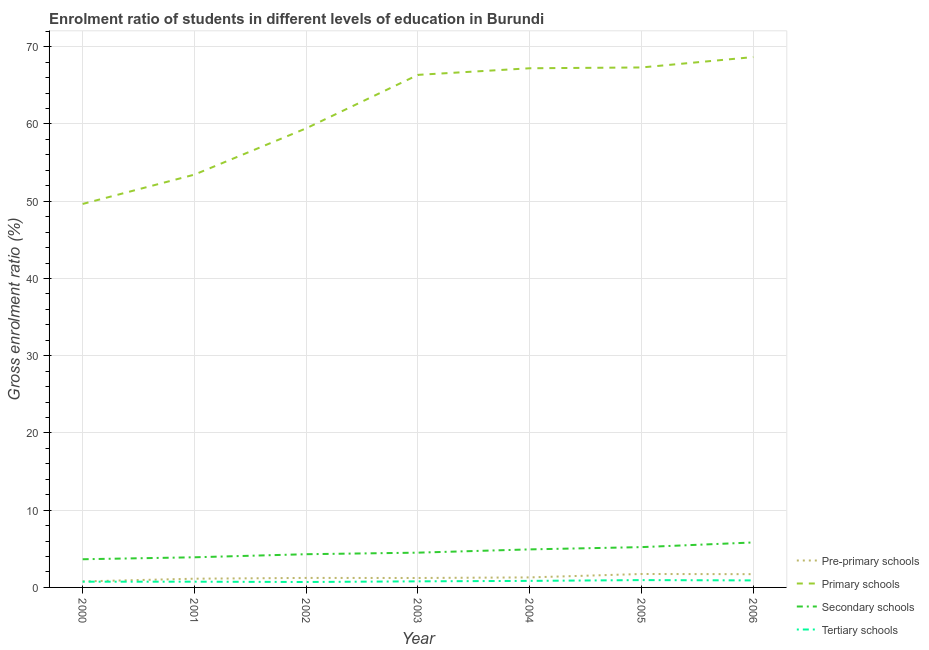How many different coloured lines are there?
Give a very brief answer. 4. Does the line corresponding to gross enrolment ratio in tertiary schools intersect with the line corresponding to gross enrolment ratio in secondary schools?
Make the answer very short. No. Is the number of lines equal to the number of legend labels?
Your response must be concise. Yes. What is the gross enrolment ratio in primary schools in 2002?
Ensure brevity in your answer.  59.44. Across all years, what is the maximum gross enrolment ratio in pre-primary schools?
Keep it short and to the point. 1.74. Across all years, what is the minimum gross enrolment ratio in pre-primary schools?
Give a very brief answer. 0.78. In which year was the gross enrolment ratio in secondary schools maximum?
Keep it short and to the point. 2006. In which year was the gross enrolment ratio in secondary schools minimum?
Ensure brevity in your answer.  2000. What is the total gross enrolment ratio in secondary schools in the graph?
Ensure brevity in your answer.  32.32. What is the difference between the gross enrolment ratio in primary schools in 2001 and that in 2002?
Your response must be concise. -5.99. What is the difference between the gross enrolment ratio in secondary schools in 2000 and the gross enrolment ratio in primary schools in 2003?
Offer a terse response. -62.71. What is the average gross enrolment ratio in pre-primary schools per year?
Give a very brief answer. 1.3. In the year 2001, what is the difference between the gross enrolment ratio in secondary schools and gross enrolment ratio in primary schools?
Keep it short and to the point. -49.54. What is the ratio of the gross enrolment ratio in pre-primary schools in 2000 to that in 2004?
Your response must be concise. 0.6. Is the gross enrolment ratio in primary schools in 2002 less than that in 2003?
Provide a succinct answer. Yes. Is the difference between the gross enrolment ratio in primary schools in 2000 and 2004 greater than the difference between the gross enrolment ratio in pre-primary schools in 2000 and 2004?
Ensure brevity in your answer.  No. What is the difference between the highest and the second highest gross enrolment ratio in tertiary schools?
Your answer should be compact. 0.04. What is the difference between the highest and the lowest gross enrolment ratio in tertiary schools?
Make the answer very short. 0.25. Is the sum of the gross enrolment ratio in tertiary schools in 2000 and 2003 greater than the maximum gross enrolment ratio in pre-primary schools across all years?
Ensure brevity in your answer.  No. Does the gross enrolment ratio in secondary schools monotonically increase over the years?
Offer a terse response. Yes. What is the difference between two consecutive major ticks on the Y-axis?
Give a very brief answer. 10. Where does the legend appear in the graph?
Make the answer very short. Bottom right. How many legend labels are there?
Keep it short and to the point. 4. What is the title of the graph?
Keep it short and to the point. Enrolment ratio of students in different levels of education in Burundi. Does "Regional development banks" appear as one of the legend labels in the graph?
Make the answer very short. No. What is the Gross enrolment ratio (%) in Pre-primary schools in 2000?
Your answer should be compact. 0.78. What is the Gross enrolment ratio (%) of Primary schools in 2000?
Ensure brevity in your answer.  49.65. What is the Gross enrolment ratio (%) of Secondary schools in 2000?
Offer a very short reply. 3.65. What is the Gross enrolment ratio (%) of Tertiary schools in 2000?
Keep it short and to the point. 0.74. What is the Gross enrolment ratio (%) of Pre-primary schools in 2001?
Your answer should be very brief. 1.13. What is the Gross enrolment ratio (%) of Primary schools in 2001?
Give a very brief answer. 53.45. What is the Gross enrolment ratio (%) in Secondary schools in 2001?
Your response must be concise. 3.9. What is the Gross enrolment ratio (%) of Tertiary schools in 2001?
Give a very brief answer. 0.74. What is the Gross enrolment ratio (%) in Pre-primary schools in 2002?
Make the answer very short. 1.23. What is the Gross enrolment ratio (%) of Primary schools in 2002?
Your answer should be compact. 59.44. What is the Gross enrolment ratio (%) of Secondary schools in 2002?
Your answer should be very brief. 4.3. What is the Gross enrolment ratio (%) of Tertiary schools in 2002?
Your response must be concise. 0.7. What is the Gross enrolment ratio (%) of Pre-primary schools in 2003?
Offer a very short reply. 1.22. What is the Gross enrolment ratio (%) in Primary schools in 2003?
Your answer should be compact. 66.36. What is the Gross enrolment ratio (%) in Secondary schools in 2003?
Provide a short and direct response. 4.5. What is the Gross enrolment ratio (%) of Tertiary schools in 2003?
Your response must be concise. 0.79. What is the Gross enrolment ratio (%) in Pre-primary schools in 2004?
Provide a succinct answer. 1.3. What is the Gross enrolment ratio (%) in Primary schools in 2004?
Keep it short and to the point. 67.22. What is the Gross enrolment ratio (%) in Secondary schools in 2004?
Offer a very short reply. 4.93. What is the Gross enrolment ratio (%) in Tertiary schools in 2004?
Offer a very short reply. 0.85. What is the Gross enrolment ratio (%) of Pre-primary schools in 2005?
Provide a short and direct response. 1.74. What is the Gross enrolment ratio (%) in Primary schools in 2005?
Your answer should be very brief. 67.32. What is the Gross enrolment ratio (%) of Secondary schools in 2005?
Your response must be concise. 5.22. What is the Gross enrolment ratio (%) in Tertiary schools in 2005?
Ensure brevity in your answer.  0.95. What is the Gross enrolment ratio (%) of Pre-primary schools in 2006?
Give a very brief answer. 1.72. What is the Gross enrolment ratio (%) of Primary schools in 2006?
Offer a very short reply. 68.67. What is the Gross enrolment ratio (%) in Secondary schools in 2006?
Offer a terse response. 5.82. What is the Gross enrolment ratio (%) in Tertiary schools in 2006?
Your answer should be very brief. 0.91. Across all years, what is the maximum Gross enrolment ratio (%) of Pre-primary schools?
Offer a very short reply. 1.74. Across all years, what is the maximum Gross enrolment ratio (%) in Primary schools?
Your answer should be compact. 68.67. Across all years, what is the maximum Gross enrolment ratio (%) in Secondary schools?
Provide a succinct answer. 5.82. Across all years, what is the maximum Gross enrolment ratio (%) in Tertiary schools?
Ensure brevity in your answer.  0.95. Across all years, what is the minimum Gross enrolment ratio (%) of Pre-primary schools?
Offer a very short reply. 0.78. Across all years, what is the minimum Gross enrolment ratio (%) of Primary schools?
Keep it short and to the point. 49.65. Across all years, what is the minimum Gross enrolment ratio (%) of Secondary schools?
Provide a short and direct response. 3.65. Across all years, what is the minimum Gross enrolment ratio (%) of Tertiary schools?
Offer a terse response. 0.7. What is the total Gross enrolment ratio (%) of Pre-primary schools in the graph?
Provide a short and direct response. 9.12. What is the total Gross enrolment ratio (%) in Primary schools in the graph?
Ensure brevity in your answer.  432.1. What is the total Gross enrolment ratio (%) in Secondary schools in the graph?
Your answer should be very brief. 32.32. What is the total Gross enrolment ratio (%) of Tertiary schools in the graph?
Offer a very short reply. 5.68. What is the difference between the Gross enrolment ratio (%) of Pre-primary schools in 2000 and that in 2001?
Ensure brevity in your answer.  -0.35. What is the difference between the Gross enrolment ratio (%) in Primary schools in 2000 and that in 2001?
Give a very brief answer. -3.8. What is the difference between the Gross enrolment ratio (%) of Secondary schools in 2000 and that in 2001?
Your answer should be very brief. -0.25. What is the difference between the Gross enrolment ratio (%) of Tertiary schools in 2000 and that in 2001?
Keep it short and to the point. 0. What is the difference between the Gross enrolment ratio (%) of Pre-primary schools in 2000 and that in 2002?
Keep it short and to the point. -0.45. What is the difference between the Gross enrolment ratio (%) of Primary schools in 2000 and that in 2002?
Provide a succinct answer. -9.79. What is the difference between the Gross enrolment ratio (%) of Secondary schools in 2000 and that in 2002?
Your response must be concise. -0.65. What is the difference between the Gross enrolment ratio (%) of Tertiary schools in 2000 and that in 2002?
Provide a succinct answer. 0.04. What is the difference between the Gross enrolment ratio (%) of Pre-primary schools in 2000 and that in 2003?
Your response must be concise. -0.44. What is the difference between the Gross enrolment ratio (%) of Primary schools in 2000 and that in 2003?
Your answer should be compact. -16.71. What is the difference between the Gross enrolment ratio (%) in Secondary schools in 2000 and that in 2003?
Provide a short and direct response. -0.85. What is the difference between the Gross enrolment ratio (%) in Tertiary schools in 2000 and that in 2003?
Give a very brief answer. -0.04. What is the difference between the Gross enrolment ratio (%) in Pre-primary schools in 2000 and that in 2004?
Offer a very short reply. -0.52. What is the difference between the Gross enrolment ratio (%) in Primary schools in 2000 and that in 2004?
Make the answer very short. -17.57. What is the difference between the Gross enrolment ratio (%) in Secondary schools in 2000 and that in 2004?
Offer a very short reply. -1.28. What is the difference between the Gross enrolment ratio (%) of Tertiary schools in 2000 and that in 2004?
Offer a very short reply. -0.1. What is the difference between the Gross enrolment ratio (%) in Pre-primary schools in 2000 and that in 2005?
Make the answer very short. -0.96. What is the difference between the Gross enrolment ratio (%) in Primary schools in 2000 and that in 2005?
Provide a short and direct response. -17.67. What is the difference between the Gross enrolment ratio (%) in Secondary schools in 2000 and that in 2005?
Provide a short and direct response. -1.57. What is the difference between the Gross enrolment ratio (%) of Tertiary schools in 2000 and that in 2005?
Offer a terse response. -0.21. What is the difference between the Gross enrolment ratio (%) of Pre-primary schools in 2000 and that in 2006?
Make the answer very short. -0.94. What is the difference between the Gross enrolment ratio (%) in Primary schools in 2000 and that in 2006?
Provide a succinct answer. -19.02. What is the difference between the Gross enrolment ratio (%) in Secondary schools in 2000 and that in 2006?
Your answer should be very brief. -2.17. What is the difference between the Gross enrolment ratio (%) in Tertiary schools in 2000 and that in 2006?
Keep it short and to the point. -0.16. What is the difference between the Gross enrolment ratio (%) in Pre-primary schools in 2001 and that in 2002?
Your response must be concise. -0.1. What is the difference between the Gross enrolment ratio (%) of Primary schools in 2001 and that in 2002?
Make the answer very short. -5.99. What is the difference between the Gross enrolment ratio (%) of Secondary schools in 2001 and that in 2002?
Provide a succinct answer. -0.4. What is the difference between the Gross enrolment ratio (%) in Tertiary schools in 2001 and that in 2002?
Offer a very short reply. 0.04. What is the difference between the Gross enrolment ratio (%) of Pre-primary schools in 2001 and that in 2003?
Your response must be concise. -0.09. What is the difference between the Gross enrolment ratio (%) in Primary schools in 2001 and that in 2003?
Make the answer very short. -12.92. What is the difference between the Gross enrolment ratio (%) in Secondary schools in 2001 and that in 2003?
Your response must be concise. -0.6. What is the difference between the Gross enrolment ratio (%) in Tertiary schools in 2001 and that in 2003?
Ensure brevity in your answer.  -0.04. What is the difference between the Gross enrolment ratio (%) in Pre-primary schools in 2001 and that in 2004?
Give a very brief answer. -0.17. What is the difference between the Gross enrolment ratio (%) in Primary schools in 2001 and that in 2004?
Your answer should be very brief. -13.77. What is the difference between the Gross enrolment ratio (%) of Secondary schools in 2001 and that in 2004?
Provide a short and direct response. -1.02. What is the difference between the Gross enrolment ratio (%) in Tertiary schools in 2001 and that in 2004?
Ensure brevity in your answer.  -0.1. What is the difference between the Gross enrolment ratio (%) of Pre-primary schools in 2001 and that in 2005?
Ensure brevity in your answer.  -0.61. What is the difference between the Gross enrolment ratio (%) of Primary schools in 2001 and that in 2005?
Your answer should be very brief. -13.87. What is the difference between the Gross enrolment ratio (%) in Secondary schools in 2001 and that in 2005?
Ensure brevity in your answer.  -1.32. What is the difference between the Gross enrolment ratio (%) of Tertiary schools in 2001 and that in 2005?
Ensure brevity in your answer.  -0.21. What is the difference between the Gross enrolment ratio (%) in Pre-primary schools in 2001 and that in 2006?
Provide a short and direct response. -0.59. What is the difference between the Gross enrolment ratio (%) of Primary schools in 2001 and that in 2006?
Offer a terse response. -15.22. What is the difference between the Gross enrolment ratio (%) in Secondary schools in 2001 and that in 2006?
Keep it short and to the point. -1.92. What is the difference between the Gross enrolment ratio (%) of Tertiary schools in 2001 and that in 2006?
Ensure brevity in your answer.  -0.16. What is the difference between the Gross enrolment ratio (%) in Pre-primary schools in 2002 and that in 2003?
Provide a short and direct response. 0.01. What is the difference between the Gross enrolment ratio (%) in Primary schools in 2002 and that in 2003?
Provide a short and direct response. -6.92. What is the difference between the Gross enrolment ratio (%) in Secondary schools in 2002 and that in 2003?
Your response must be concise. -0.2. What is the difference between the Gross enrolment ratio (%) in Tertiary schools in 2002 and that in 2003?
Keep it short and to the point. -0.08. What is the difference between the Gross enrolment ratio (%) of Pre-primary schools in 2002 and that in 2004?
Give a very brief answer. -0.07. What is the difference between the Gross enrolment ratio (%) of Primary schools in 2002 and that in 2004?
Your answer should be compact. -7.78. What is the difference between the Gross enrolment ratio (%) in Secondary schools in 2002 and that in 2004?
Give a very brief answer. -0.63. What is the difference between the Gross enrolment ratio (%) of Tertiary schools in 2002 and that in 2004?
Provide a short and direct response. -0.14. What is the difference between the Gross enrolment ratio (%) in Pre-primary schools in 2002 and that in 2005?
Your answer should be compact. -0.51. What is the difference between the Gross enrolment ratio (%) in Primary schools in 2002 and that in 2005?
Your answer should be very brief. -7.88. What is the difference between the Gross enrolment ratio (%) of Secondary schools in 2002 and that in 2005?
Ensure brevity in your answer.  -0.92. What is the difference between the Gross enrolment ratio (%) in Tertiary schools in 2002 and that in 2005?
Offer a terse response. -0.25. What is the difference between the Gross enrolment ratio (%) of Pre-primary schools in 2002 and that in 2006?
Provide a succinct answer. -0.49. What is the difference between the Gross enrolment ratio (%) of Primary schools in 2002 and that in 2006?
Ensure brevity in your answer.  -9.22. What is the difference between the Gross enrolment ratio (%) in Secondary schools in 2002 and that in 2006?
Give a very brief answer. -1.52. What is the difference between the Gross enrolment ratio (%) of Tertiary schools in 2002 and that in 2006?
Provide a succinct answer. -0.2. What is the difference between the Gross enrolment ratio (%) of Pre-primary schools in 2003 and that in 2004?
Offer a terse response. -0.07. What is the difference between the Gross enrolment ratio (%) in Primary schools in 2003 and that in 2004?
Provide a succinct answer. -0.85. What is the difference between the Gross enrolment ratio (%) of Secondary schools in 2003 and that in 2004?
Your answer should be very brief. -0.42. What is the difference between the Gross enrolment ratio (%) in Tertiary schools in 2003 and that in 2004?
Your answer should be very brief. -0.06. What is the difference between the Gross enrolment ratio (%) in Pre-primary schools in 2003 and that in 2005?
Provide a succinct answer. -0.52. What is the difference between the Gross enrolment ratio (%) of Primary schools in 2003 and that in 2005?
Keep it short and to the point. -0.96. What is the difference between the Gross enrolment ratio (%) in Secondary schools in 2003 and that in 2005?
Your answer should be very brief. -0.72. What is the difference between the Gross enrolment ratio (%) of Tertiary schools in 2003 and that in 2005?
Offer a very short reply. -0.16. What is the difference between the Gross enrolment ratio (%) in Pre-primary schools in 2003 and that in 2006?
Keep it short and to the point. -0.49. What is the difference between the Gross enrolment ratio (%) of Primary schools in 2003 and that in 2006?
Provide a short and direct response. -2.3. What is the difference between the Gross enrolment ratio (%) of Secondary schools in 2003 and that in 2006?
Your response must be concise. -1.32. What is the difference between the Gross enrolment ratio (%) in Tertiary schools in 2003 and that in 2006?
Ensure brevity in your answer.  -0.12. What is the difference between the Gross enrolment ratio (%) in Pre-primary schools in 2004 and that in 2005?
Ensure brevity in your answer.  -0.44. What is the difference between the Gross enrolment ratio (%) in Primary schools in 2004 and that in 2005?
Provide a short and direct response. -0.1. What is the difference between the Gross enrolment ratio (%) in Secondary schools in 2004 and that in 2005?
Provide a succinct answer. -0.29. What is the difference between the Gross enrolment ratio (%) of Tertiary schools in 2004 and that in 2005?
Offer a terse response. -0.1. What is the difference between the Gross enrolment ratio (%) in Pre-primary schools in 2004 and that in 2006?
Give a very brief answer. -0.42. What is the difference between the Gross enrolment ratio (%) in Primary schools in 2004 and that in 2006?
Give a very brief answer. -1.45. What is the difference between the Gross enrolment ratio (%) in Secondary schools in 2004 and that in 2006?
Keep it short and to the point. -0.9. What is the difference between the Gross enrolment ratio (%) in Tertiary schools in 2004 and that in 2006?
Make the answer very short. -0.06. What is the difference between the Gross enrolment ratio (%) in Pre-primary schools in 2005 and that in 2006?
Your answer should be very brief. 0.02. What is the difference between the Gross enrolment ratio (%) of Primary schools in 2005 and that in 2006?
Your answer should be compact. -1.34. What is the difference between the Gross enrolment ratio (%) in Secondary schools in 2005 and that in 2006?
Ensure brevity in your answer.  -0.6. What is the difference between the Gross enrolment ratio (%) in Tertiary schools in 2005 and that in 2006?
Your response must be concise. 0.04. What is the difference between the Gross enrolment ratio (%) in Pre-primary schools in 2000 and the Gross enrolment ratio (%) in Primary schools in 2001?
Your answer should be compact. -52.67. What is the difference between the Gross enrolment ratio (%) in Pre-primary schools in 2000 and the Gross enrolment ratio (%) in Secondary schools in 2001?
Make the answer very short. -3.12. What is the difference between the Gross enrolment ratio (%) of Pre-primary schools in 2000 and the Gross enrolment ratio (%) of Tertiary schools in 2001?
Provide a succinct answer. 0.04. What is the difference between the Gross enrolment ratio (%) of Primary schools in 2000 and the Gross enrolment ratio (%) of Secondary schools in 2001?
Offer a very short reply. 45.75. What is the difference between the Gross enrolment ratio (%) of Primary schools in 2000 and the Gross enrolment ratio (%) of Tertiary schools in 2001?
Your answer should be compact. 48.91. What is the difference between the Gross enrolment ratio (%) of Secondary schools in 2000 and the Gross enrolment ratio (%) of Tertiary schools in 2001?
Make the answer very short. 2.91. What is the difference between the Gross enrolment ratio (%) in Pre-primary schools in 2000 and the Gross enrolment ratio (%) in Primary schools in 2002?
Ensure brevity in your answer.  -58.66. What is the difference between the Gross enrolment ratio (%) of Pre-primary schools in 2000 and the Gross enrolment ratio (%) of Secondary schools in 2002?
Keep it short and to the point. -3.52. What is the difference between the Gross enrolment ratio (%) of Pre-primary schools in 2000 and the Gross enrolment ratio (%) of Tertiary schools in 2002?
Give a very brief answer. 0.07. What is the difference between the Gross enrolment ratio (%) in Primary schools in 2000 and the Gross enrolment ratio (%) in Secondary schools in 2002?
Offer a terse response. 45.35. What is the difference between the Gross enrolment ratio (%) of Primary schools in 2000 and the Gross enrolment ratio (%) of Tertiary schools in 2002?
Make the answer very short. 48.95. What is the difference between the Gross enrolment ratio (%) in Secondary schools in 2000 and the Gross enrolment ratio (%) in Tertiary schools in 2002?
Ensure brevity in your answer.  2.95. What is the difference between the Gross enrolment ratio (%) of Pre-primary schools in 2000 and the Gross enrolment ratio (%) of Primary schools in 2003?
Give a very brief answer. -65.58. What is the difference between the Gross enrolment ratio (%) of Pre-primary schools in 2000 and the Gross enrolment ratio (%) of Secondary schools in 2003?
Provide a short and direct response. -3.72. What is the difference between the Gross enrolment ratio (%) in Pre-primary schools in 2000 and the Gross enrolment ratio (%) in Tertiary schools in 2003?
Offer a terse response. -0.01. What is the difference between the Gross enrolment ratio (%) of Primary schools in 2000 and the Gross enrolment ratio (%) of Secondary schools in 2003?
Your answer should be very brief. 45.15. What is the difference between the Gross enrolment ratio (%) of Primary schools in 2000 and the Gross enrolment ratio (%) of Tertiary schools in 2003?
Offer a terse response. 48.86. What is the difference between the Gross enrolment ratio (%) in Secondary schools in 2000 and the Gross enrolment ratio (%) in Tertiary schools in 2003?
Make the answer very short. 2.86. What is the difference between the Gross enrolment ratio (%) of Pre-primary schools in 2000 and the Gross enrolment ratio (%) of Primary schools in 2004?
Keep it short and to the point. -66.44. What is the difference between the Gross enrolment ratio (%) in Pre-primary schools in 2000 and the Gross enrolment ratio (%) in Secondary schools in 2004?
Provide a succinct answer. -4.15. What is the difference between the Gross enrolment ratio (%) of Pre-primary schools in 2000 and the Gross enrolment ratio (%) of Tertiary schools in 2004?
Your response must be concise. -0.07. What is the difference between the Gross enrolment ratio (%) of Primary schools in 2000 and the Gross enrolment ratio (%) of Secondary schools in 2004?
Provide a short and direct response. 44.72. What is the difference between the Gross enrolment ratio (%) in Primary schools in 2000 and the Gross enrolment ratio (%) in Tertiary schools in 2004?
Your answer should be very brief. 48.8. What is the difference between the Gross enrolment ratio (%) of Secondary schools in 2000 and the Gross enrolment ratio (%) of Tertiary schools in 2004?
Keep it short and to the point. 2.8. What is the difference between the Gross enrolment ratio (%) in Pre-primary schools in 2000 and the Gross enrolment ratio (%) in Primary schools in 2005?
Offer a very short reply. -66.54. What is the difference between the Gross enrolment ratio (%) of Pre-primary schools in 2000 and the Gross enrolment ratio (%) of Secondary schools in 2005?
Make the answer very short. -4.44. What is the difference between the Gross enrolment ratio (%) of Pre-primary schools in 2000 and the Gross enrolment ratio (%) of Tertiary schools in 2005?
Provide a short and direct response. -0.17. What is the difference between the Gross enrolment ratio (%) in Primary schools in 2000 and the Gross enrolment ratio (%) in Secondary schools in 2005?
Keep it short and to the point. 44.43. What is the difference between the Gross enrolment ratio (%) of Primary schools in 2000 and the Gross enrolment ratio (%) of Tertiary schools in 2005?
Offer a very short reply. 48.7. What is the difference between the Gross enrolment ratio (%) in Secondary schools in 2000 and the Gross enrolment ratio (%) in Tertiary schools in 2005?
Make the answer very short. 2.7. What is the difference between the Gross enrolment ratio (%) in Pre-primary schools in 2000 and the Gross enrolment ratio (%) in Primary schools in 2006?
Your answer should be compact. -67.89. What is the difference between the Gross enrolment ratio (%) of Pre-primary schools in 2000 and the Gross enrolment ratio (%) of Secondary schools in 2006?
Ensure brevity in your answer.  -5.04. What is the difference between the Gross enrolment ratio (%) in Pre-primary schools in 2000 and the Gross enrolment ratio (%) in Tertiary schools in 2006?
Your answer should be very brief. -0.13. What is the difference between the Gross enrolment ratio (%) in Primary schools in 2000 and the Gross enrolment ratio (%) in Secondary schools in 2006?
Your response must be concise. 43.83. What is the difference between the Gross enrolment ratio (%) of Primary schools in 2000 and the Gross enrolment ratio (%) of Tertiary schools in 2006?
Make the answer very short. 48.74. What is the difference between the Gross enrolment ratio (%) of Secondary schools in 2000 and the Gross enrolment ratio (%) of Tertiary schools in 2006?
Your response must be concise. 2.74. What is the difference between the Gross enrolment ratio (%) of Pre-primary schools in 2001 and the Gross enrolment ratio (%) of Primary schools in 2002?
Your answer should be compact. -58.31. What is the difference between the Gross enrolment ratio (%) in Pre-primary schools in 2001 and the Gross enrolment ratio (%) in Secondary schools in 2002?
Offer a very short reply. -3.17. What is the difference between the Gross enrolment ratio (%) in Pre-primary schools in 2001 and the Gross enrolment ratio (%) in Tertiary schools in 2002?
Keep it short and to the point. 0.43. What is the difference between the Gross enrolment ratio (%) in Primary schools in 2001 and the Gross enrolment ratio (%) in Secondary schools in 2002?
Provide a short and direct response. 49.15. What is the difference between the Gross enrolment ratio (%) in Primary schools in 2001 and the Gross enrolment ratio (%) in Tertiary schools in 2002?
Your response must be concise. 52.74. What is the difference between the Gross enrolment ratio (%) in Secondary schools in 2001 and the Gross enrolment ratio (%) in Tertiary schools in 2002?
Your answer should be compact. 3.2. What is the difference between the Gross enrolment ratio (%) of Pre-primary schools in 2001 and the Gross enrolment ratio (%) of Primary schools in 2003?
Your answer should be very brief. -65.23. What is the difference between the Gross enrolment ratio (%) of Pre-primary schools in 2001 and the Gross enrolment ratio (%) of Secondary schools in 2003?
Provide a short and direct response. -3.37. What is the difference between the Gross enrolment ratio (%) of Pre-primary schools in 2001 and the Gross enrolment ratio (%) of Tertiary schools in 2003?
Your response must be concise. 0.34. What is the difference between the Gross enrolment ratio (%) of Primary schools in 2001 and the Gross enrolment ratio (%) of Secondary schools in 2003?
Provide a short and direct response. 48.94. What is the difference between the Gross enrolment ratio (%) in Primary schools in 2001 and the Gross enrolment ratio (%) in Tertiary schools in 2003?
Your response must be concise. 52.66. What is the difference between the Gross enrolment ratio (%) in Secondary schools in 2001 and the Gross enrolment ratio (%) in Tertiary schools in 2003?
Make the answer very short. 3.12. What is the difference between the Gross enrolment ratio (%) in Pre-primary schools in 2001 and the Gross enrolment ratio (%) in Primary schools in 2004?
Keep it short and to the point. -66.09. What is the difference between the Gross enrolment ratio (%) in Pre-primary schools in 2001 and the Gross enrolment ratio (%) in Secondary schools in 2004?
Offer a terse response. -3.79. What is the difference between the Gross enrolment ratio (%) in Pre-primary schools in 2001 and the Gross enrolment ratio (%) in Tertiary schools in 2004?
Make the answer very short. 0.28. What is the difference between the Gross enrolment ratio (%) of Primary schools in 2001 and the Gross enrolment ratio (%) of Secondary schools in 2004?
Keep it short and to the point. 48.52. What is the difference between the Gross enrolment ratio (%) in Primary schools in 2001 and the Gross enrolment ratio (%) in Tertiary schools in 2004?
Provide a short and direct response. 52.6. What is the difference between the Gross enrolment ratio (%) of Secondary schools in 2001 and the Gross enrolment ratio (%) of Tertiary schools in 2004?
Your answer should be compact. 3.06. What is the difference between the Gross enrolment ratio (%) of Pre-primary schools in 2001 and the Gross enrolment ratio (%) of Primary schools in 2005?
Ensure brevity in your answer.  -66.19. What is the difference between the Gross enrolment ratio (%) in Pre-primary schools in 2001 and the Gross enrolment ratio (%) in Secondary schools in 2005?
Provide a succinct answer. -4.09. What is the difference between the Gross enrolment ratio (%) in Pre-primary schools in 2001 and the Gross enrolment ratio (%) in Tertiary schools in 2005?
Give a very brief answer. 0.18. What is the difference between the Gross enrolment ratio (%) of Primary schools in 2001 and the Gross enrolment ratio (%) of Secondary schools in 2005?
Ensure brevity in your answer.  48.23. What is the difference between the Gross enrolment ratio (%) in Primary schools in 2001 and the Gross enrolment ratio (%) in Tertiary schools in 2005?
Your response must be concise. 52.5. What is the difference between the Gross enrolment ratio (%) in Secondary schools in 2001 and the Gross enrolment ratio (%) in Tertiary schools in 2005?
Your answer should be very brief. 2.95. What is the difference between the Gross enrolment ratio (%) in Pre-primary schools in 2001 and the Gross enrolment ratio (%) in Primary schools in 2006?
Offer a terse response. -67.53. What is the difference between the Gross enrolment ratio (%) in Pre-primary schools in 2001 and the Gross enrolment ratio (%) in Secondary schools in 2006?
Make the answer very short. -4.69. What is the difference between the Gross enrolment ratio (%) of Pre-primary schools in 2001 and the Gross enrolment ratio (%) of Tertiary schools in 2006?
Provide a succinct answer. 0.22. What is the difference between the Gross enrolment ratio (%) in Primary schools in 2001 and the Gross enrolment ratio (%) in Secondary schools in 2006?
Make the answer very short. 47.62. What is the difference between the Gross enrolment ratio (%) of Primary schools in 2001 and the Gross enrolment ratio (%) of Tertiary schools in 2006?
Offer a terse response. 52.54. What is the difference between the Gross enrolment ratio (%) in Secondary schools in 2001 and the Gross enrolment ratio (%) in Tertiary schools in 2006?
Keep it short and to the point. 3. What is the difference between the Gross enrolment ratio (%) of Pre-primary schools in 2002 and the Gross enrolment ratio (%) of Primary schools in 2003?
Your answer should be compact. -65.13. What is the difference between the Gross enrolment ratio (%) of Pre-primary schools in 2002 and the Gross enrolment ratio (%) of Secondary schools in 2003?
Keep it short and to the point. -3.27. What is the difference between the Gross enrolment ratio (%) in Pre-primary schools in 2002 and the Gross enrolment ratio (%) in Tertiary schools in 2003?
Make the answer very short. 0.44. What is the difference between the Gross enrolment ratio (%) of Primary schools in 2002 and the Gross enrolment ratio (%) of Secondary schools in 2003?
Make the answer very short. 54.94. What is the difference between the Gross enrolment ratio (%) in Primary schools in 2002 and the Gross enrolment ratio (%) in Tertiary schools in 2003?
Offer a terse response. 58.65. What is the difference between the Gross enrolment ratio (%) of Secondary schools in 2002 and the Gross enrolment ratio (%) of Tertiary schools in 2003?
Give a very brief answer. 3.51. What is the difference between the Gross enrolment ratio (%) of Pre-primary schools in 2002 and the Gross enrolment ratio (%) of Primary schools in 2004?
Your response must be concise. -65.99. What is the difference between the Gross enrolment ratio (%) of Pre-primary schools in 2002 and the Gross enrolment ratio (%) of Secondary schools in 2004?
Provide a short and direct response. -3.69. What is the difference between the Gross enrolment ratio (%) of Pre-primary schools in 2002 and the Gross enrolment ratio (%) of Tertiary schools in 2004?
Offer a very short reply. 0.38. What is the difference between the Gross enrolment ratio (%) in Primary schools in 2002 and the Gross enrolment ratio (%) in Secondary schools in 2004?
Your answer should be very brief. 54.52. What is the difference between the Gross enrolment ratio (%) in Primary schools in 2002 and the Gross enrolment ratio (%) in Tertiary schools in 2004?
Ensure brevity in your answer.  58.59. What is the difference between the Gross enrolment ratio (%) in Secondary schools in 2002 and the Gross enrolment ratio (%) in Tertiary schools in 2004?
Your answer should be compact. 3.45. What is the difference between the Gross enrolment ratio (%) of Pre-primary schools in 2002 and the Gross enrolment ratio (%) of Primary schools in 2005?
Ensure brevity in your answer.  -66.09. What is the difference between the Gross enrolment ratio (%) of Pre-primary schools in 2002 and the Gross enrolment ratio (%) of Secondary schools in 2005?
Provide a succinct answer. -3.99. What is the difference between the Gross enrolment ratio (%) of Pre-primary schools in 2002 and the Gross enrolment ratio (%) of Tertiary schools in 2005?
Offer a terse response. 0.28. What is the difference between the Gross enrolment ratio (%) in Primary schools in 2002 and the Gross enrolment ratio (%) in Secondary schools in 2005?
Offer a very short reply. 54.22. What is the difference between the Gross enrolment ratio (%) of Primary schools in 2002 and the Gross enrolment ratio (%) of Tertiary schools in 2005?
Ensure brevity in your answer.  58.49. What is the difference between the Gross enrolment ratio (%) of Secondary schools in 2002 and the Gross enrolment ratio (%) of Tertiary schools in 2005?
Provide a short and direct response. 3.35. What is the difference between the Gross enrolment ratio (%) of Pre-primary schools in 2002 and the Gross enrolment ratio (%) of Primary schools in 2006?
Give a very brief answer. -67.43. What is the difference between the Gross enrolment ratio (%) of Pre-primary schools in 2002 and the Gross enrolment ratio (%) of Secondary schools in 2006?
Give a very brief answer. -4.59. What is the difference between the Gross enrolment ratio (%) of Pre-primary schools in 2002 and the Gross enrolment ratio (%) of Tertiary schools in 2006?
Keep it short and to the point. 0.32. What is the difference between the Gross enrolment ratio (%) of Primary schools in 2002 and the Gross enrolment ratio (%) of Secondary schools in 2006?
Your response must be concise. 53.62. What is the difference between the Gross enrolment ratio (%) in Primary schools in 2002 and the Gross enrolment ratio (%) in Tertiary schools in 2006?
Your response must be concise. 58.53. What is the difference between the Gross enrolment ratio (%) of Secondary schools in 2002 and the Gross enrolment ratio (%) of Tertiary schools in 2006?
Provide a succinct answer. 3.39. What is the difference between the Gross enrolment ratio (%) of Pre-primary schools in 2003 and the Gross enrolment ratio (%) of Primary schools in 2004?
Provide a succinct answer. -65.99. What is the difference between the Gross enrolment ratio (%) of Pre-primary schools in 2003 and the Gross enrolment ratio (%) of Secondary schools in 2004?
Your response must be concise. -3.7. What is the difference between the Gross enrolment ratio (%) in Pre-primary schools in 2003 and the Gross enrolment ratio (%) in Tertiary schools in 2004?
Make the answer very short. 0.38. What is the difference between the Gross enrolment ratio (%) of Primary schools in 2003 and the Gross enrolment ratio (%) of Secondary schools in 2004?
Your answer should be very brief. 61.44. What is the difference between the Gross enrolment ratio (%) in Primary schools in 2003 and the Gross enrolment ratio (%) in Tertiary schools in 2004?
Provide a short and direct response. 65.52. What is the difference between the Gross enrolment ratio (%) of Secondary schools in 2003 and the Gross enrolment ratio (%) of Tertiary schools in 2004?
Offer a very short reply. 3.66. What is the difference between the Gross enrolment ratio (%) in Pre-primary schools in 2003 and the Gross enrolment ratio (%) in Primary schools in 2005?
Your response must be concise. -66.1. What is the difference between the Gross enrolment ratio (%) of Pre-primary schools in 2003 and the Gross enrolment ratio (%) of Secondary schools in 2005?
Your answer should be very brief. -4. What is the difference between the Gross enrolment ratio (%) of Pre-primary schools in 2003 and the Gross enrolment ratio (%) of Tertiary schools in 2005?
Provide a short and direct response. 0.27. What is the difference between the Gross enrolment ratio (%) in Primary schools in 2003 and the Gross enrolment ratio (%) in Secondary schools in 2005?
Your answer should be compact. 61.14. What is the difference between the Gross enrolment ratio (%) in Primary schools in 2003 and the Gross enrolment ratio (%) in Tertiary schools in 2005?
Make the answer very short. 65.41. What is the difference between the Gross enrolment ratio (%) in Secondary schools in 2003 and the Gross enrolment ratio (%) in Tertiary schools in 2005?
Make the answer very short. 3.55. What is the difference between the Gross enrolment ratio (%) in Pre-primary schools in 2003 and the Gross enrolment ratio (%) in Primary schools in 2006?
Your response must be concise. -67.44. What is the difference between the Gross enrolment ratio (%) in Pre-primary schools in 2003 and the Gross enrolment ratio (%) in Secondary schools in 2006?
Keep it short and to the point. -4.6. What is the difference between the Gross enrolment ratio (%) of Pre-primary schools in 2003 and the Gross enrolment ratio (%) of Tertiary schools in 2006?
Offer a terse response. 0.32. What is the difference between the Gross enrolment ratio (%) in Primary schools in 2003 and the Gross enrolment ratio (%) in Secondary schools in 2006?
Offer a terse response. 60.54. What is the difference between the Gross enrolment ratio (%) in Primary schools in 2003 and the Gross enrolment ratio (%) in Tertiary schools in 2006?
Offer a terse response. 65.46. What is the difference between the Gross enrolment ratio (%) of Secondary schools in 2003 and the Gross enrolment ratio (%) of Tertiary schools in 2006?
Make the answer very short. 3.59. What is the difference between the Gross enrolment ratio (%) of Pre-primary schools in 2004 and the Gross enrolment ratio (%) of Primary schools in 2005?
Your answer should be compact. -66.02. What is the difference between the Gross enrolment ratio (%) of Pre-primary schools in 2004 and the Gross enrolment ratio (%) of Secondary schools in 2005?
Provide a short and direct response. -3.92. What is the difference between the Gross enrolment ratio (%) of Pre-primary schools in 2004 and the Gross enrolment ratio (%) of Tertiary schools in 2005?
Offer a very short reply. 0.35. What is the difference between the Gross enrolment ratio (%) of Primary schools in 2004 and the Gross enrolment ratio (%) of Secondary schools in 2005?
Keep it short and to the point. 62. What is the difference between the Gross enrolment ratio (%) in Primary schools in 2004 and the Gross enrolment ratio (%) in Tertiary schools in 2005?
Ensure brevity in your answer.  66.27. What is the difference between the Gross enrolment ratio (%) in Secondary schools in 2004 and the Gross enrolment ratio (%) in Tertiary schools in 2005?
Give a very brief answer. 3.98. What is the difference between the Gross enrolment ratio (%) in Pre-primary schools in 2004 and the Gross enrolment ratio (%) in Primary schools in 2006?
Provide a succinct answer. -67.37. What is the difference between the Gross enrolment ratio (%) in Pre-primary schools in 2004 and the Gross enrolment ratio (%) in Secondary schools in 2006?
Your response must be concise. -4.52. What is the difference between the Gross enrolment ratio (%) in Pre-primary schools in 2004 and the Gross enrolment ratio (%) in Tertiary schools in 2006?
Provide a short and direct response. 0.39. What is the difference between the Gross enrolment ratio (%) in Primary schools in 2004 and the Gross enrolment ratio (%) in Secondary schools in 2006?
Provide a short and direct response. 61.39. What is the difference between the Gross enrolment ratio (%) in Primary schools in 2004 and the Gross enrolment ratio (%) in Tertiary schools in 2006?
Your response must be concise. 66.31. What is the difference between the Gross enrolment ratio (%) of Secondary schools in 2004 and the Gross enrolment ratio (%) of Tertiary schools in 2006?
Offer a terse response. 4.02. What is the difference between the Gross enrolment ratio (%) of Pre-primary schools in 2005 and the Gross enrolment ratio (%) of Primary schools in 2006?
Your answer should be very brief. -66.93. What is the difference between the Gross enrolment ratio (%) of Pre-primary schools in 2005 and the Gross enrolment ratio (%) of Secondary schools in 2006?
Ensure brevity in your answer.  -4.08. What is the difference between the Gross enrolment ratio (%) in Pre-primary schools in 2005 and the Gross enrolment ratio (%) in Tertiary schools in 2006?
Provide a short and direct response. 0.83. What is the difference between the Gross enrolment ratio (%) in Primary schools in 2005 and the Gross enrolment ratio (%) in Secondary schools in 2006?
Offer a very short reply. 61.5. What is the difference between the Gross enrolment ratio (%) in Primary schools in 2005 and the Gross enrolment ratio (%) in Tertiary schools in 2006?
Offer a very short reply. 66.41. What is the difference between the Gross enrolment ratio (%) in Secondary schools in 2005 and the Gross enrolment ratio (%) in Tertiary schools in 2006?
Make the answer very short. 4.31. What is the average Gross enrolment ratio (%) of Pre-primary schools per year?
Provide a short and direct response. 1.3. What is the average Gross enrolment ratio (%) of Primary schools per year?
Your answer should be very brief. 61.73. What is the average Gross enrolment ratio (%) of Secondary schools per year?
Offer a very short reply. 4.62. What is the average Gross enrolment ratio (%) in Tertiary schools per year?
Your answer should be very brief. 0.81. In the year 2000, what is the difference between the Gross enrolment ratio (%) of Pre-primary schools and Gross enrolment ratio (%) of Primary schools?
Make the answer very short. -48.87. In the year 2000, what is the difference between the Gross enrolment ratio (%) of Pre-primary schools and Gross enrolment ratio (%) of Secondary schools?
Keep it short and to the point. -2.87. In the year 2000, what is the difference between the Gross enrolment ratio (%) of Pre-primary schools and Gross enrolment ratio (%) of Tertiary schools?
Provide a short and direct response. 0.04. In the year 2000, what is the difference between the Gross enrolment ratio (%) of Primary schools and Gross enrolment ratio (%) of Secondary schools?
Make the answer very short. 46. In the year 2000, what is the difference between the Gross enrolment ratio (%) in Primary schools and Gross enrolment ratio (%) in Tertiary schools?
Offer a very short reply. 48.91. In the year 2000, what is the difference between the Gross enrolment ratio (%) in Secondary schools and Gross enrolment ratio (%) in Tertiary schools?
Provide a succinct answer. 2.91. In the year 2001, what is the difference between the Gross enrolment ratio (%) in Pre-primary schools and Gross enrolment ratio (%) in Primary schools?
Keep it short and to the point. -52.32. In the year 2001, what is the difference between the Gross enrolment ratio (%) of Pre-primary schools and Gross enrolment ratio (%) of Secondary schools?
Your response must be concise. -2.77. In the year 2001, what is the difference between the Gross enrolment ratio (%) in Pre-primary schools and Gross enrolment ratio (%) in Tertiary schools?
Your response must be concise. 0.39. In the year 2001, what is the difference between the Gross enrolment ratio (%) in Primary schools and Gross enrolment ratio (%) in Secondary schools?
Your answer should be very brief. 49.54. In the year 2001, what is the difference between the Gross enrolment ratio (%) of Primary schools and Gross enrolment ratio (%) of Tertiary schools?
Ensure brevity in your answer.  52.7. In the year 2001, what is the difference between the Gross enrolment ratio (%) in Secondary schools and Gross enrolment ratio (%) in Tertiary schools?
Keep it short and to the point. 3.16. In the year 2002, what is the difference between the Gross enrolment ratio (%) of Pre-primary schools and Gross enrolment ratio (%) of Primary schools?
Your answer should be compact. -58.21. In the year 2002, what is the difference between the Gross enrolment ratio (%) in Pre-primary schools and Gross enrolment ratio (%) in Secondary schools?
Make the answer very short. -3.07. In the year 2002, what is the difference between the Gross enrolment ratio (%) of Pre-primary schools and Gross enrolment ratio (%) of Tertiary schools?
Offer a terse response. 0.53. In the year 2002, what is the difference between the Gross enrolment ratio (%) of Primary schools and Gross enrolment ratio (%) of Secondary schools?
Make the answer very short. 55.14. In the year 2002, what is the difference between the Gross enrolment ratio (%) in Primary schools and Gross enrolment ratio (%) in Tertiary schools?
Offer a very short reply. 58.74. In the year 2002, what is the difference between the Gross enrolment ratio (%) in Secondary schools and Gross enrolment ratio (%) in Tertiary schools?
Keep it short and to the point. 3.6. In the year 2003, what is the difference between the Gross enrolment ratio (%) of Pre-primary schools and Gross enrolment ratio (%) of Primary schools?
Your response must be concise. -65.14. In the year 2003, what is the difference between the Gross enrolment ratio (%) of Pre-primary schools and Gross enrolment ratio (%) of Secondary schools?
Provide a succinct answer. -3.28. In the year 2003, what is the difference between the Gross enrolment ratio (%) in Pre-primary schools and Gross enrolment ratio (%) in Tertiary schools?
Keep it short and to the point. 0.44. In the year 2003, what is the difference between the Gross enrolment ratio (%) of Primary schools and Gross enrolment ratio (%) of Secondary schools?
Give a very brief answer. 61.86. In the year 2003, what is the difference between the Gross enrolment ratio (%) in Primary schools and Gross enrolment ratio (%) in Tertiary schools?
Your answer should be compact. 65.58. In the year 2003, what is the difference between the Gross enrolment ratio (%) in Secondary schools and Gross enrolment ratio (%) in Tertiary schools?
Your answer should be very brief. 3.71. In the year 2004, what is the difference between the Gross enrolment ratio (%) in Pre-primary schools and Gross enrolment ratio (%) in Primary schools?
Provide a succinct answer. -65.92. In the year 2004, what is the difference between the Gross enrolment ratio (%) in Pre-primary schools and Gross enrolment ratio (%) in Secondary schools?
Offer a terse response. -3.63. In the year 2004, what is the difference between the Gross enrolment ratio (%) of Pre-primary schools and Gross enrolment ratio (%) of Tertiary schools?
Your answer should be compact. 0.45. In the year 2004, what is the difference between the Gross enrolment ratio (%) in Primary schools and Gross enrolment ratio (%) in Secondary schools?
Provide a succinct answer. 62.29. In the year 2004, what is the difference between the Gross enrolment ratio (%) of Primary schools and Gross enrolment ratio (%) of Tertiary schools?
Provide a succinct answer. 66.37. In the year 2004, what is the difference between the Gross enrolment ratio (%) in Secondary schools and Gross enrolment ratio (%) in Tertiary schools?
Ensure brevity in your answer.  4.08. In the year 2005, what is the difference between the Gross enrolment ratio (%) in Pre-primary schools and Gross enrolment ratio (%) in Primary schools?
Keep it short and to the point. -65.58. In the year 2005, what is the difference between the Gross enrolment ratio (%) of Pre-primary schools and Gross enrolment ratio (%) of Secondary schools?
Provide a succinct answer. -3.48. In the year 2005, what is the difference between the Gross enrolment ratio (%) of Pre-primary schools and Gross enrolment ratio (%) of Tertiary schools?
Your response must be concise. 0.79. In the year 2005, what is the difference between the Gross enrolment ratio (%) in Primary schools and Gross enrolment ratio (%) in Secondary schools?
Offer a very short reply. 62.1. In the year 2005, what is the difference between the Gross enrolment ratio (%) of Primary schools and Gross enrolment ratio (%) of Tertiary schools?
Offer a terse response. 66.37. In the year 2005, what is the difference between the Gross enrolment ratio (%) in Secondary schools and Gross enrolment ratio (%) in Tertiary schools?
Make the answer very short. 4.27. In the year 2006, what is the difference between the Gross enrolment ratio (%) of Pre-primary schools and Gross enrolment ratio (%) of Primary schools?
Make the answer very short. -66.95. In the year 2006, what is the difference between the Gross enrolment ratio (%) of Pre-primary schools and Gross enrolment ratio (%) of Secondary schools?
Give a very brief answer. -4.11. In the year 2006, what is the difference between the Gross enrolment ratio (%) of Pre-primary schools and Gross enrolment ratio (%) of Tertiary schools?
Make the answer very short. 0.81. In the year 2006, what is the difference between the Gross enrolment ratio (%) in Primary schools and Gross enrolment ratio (%) in Secondary schools?
Offer a terse response. 62.84. In the year 2006, what is the difference between the Gross enrolment ratio (%) in Primary schools and Gross enrolment ratio (%) in Tertiary schools?
Offer a terse response. 67.76. In the year 2006, what is the difference between the Gross enrolment ratio (%) of Secondary schools and Gross enrolment ratio (%) of Tertiary schools?
Your answer should be compact. 4.91. What is the ratio of the Gross enrolment ratio (%) of Pre-primary schools in 2000 to that in 2001?
Your answer should be compact. 0.69. What is the ratio of the Gross enrolment ratio (%) in Primary schools in 2000 to that in 2001?
Keep it short and to the point. 0.93. What is the ratio of the Gross enrolment ratio (%) of Secondary schools in 2000 to that in 2001?
Offer a very short reply. 0.93. What is the ratio of the Gross enrolment ratio (%) in Pre-primary schools in 2000 to that in 2002?
Offer a very short reply. 0.63. What is the ratio of the Gross enrolment ratio (%) in Primary schools in 2000 to that in 2002?
Offer a very short reply. 0.84. What is the ratio of the Gross enrolment ratio (%) of Secondary schools in 2000 to that in 2002?
Your response must be concise. 0.85. What is the ratio of the Gross enrolment ratio (%) in Tertiary schools in 2000 to that in 2002?
Provide a short and direct response. 1.06. What is the ratio of the Gross enrolment ratio (%) of Pre-primary schools in 2000 to that in 2003?
Provide a short and direct response. 0.64. What is the ratio of the Gross enrolment ratio (%) in Primary schools in 2000 to that in 2003?
Ensure brevity in your answer.  0.75. What is the ratio of the Gross enrolment ratio (%) of Secondary schools in 2000 to that in 2003?
Keep it short and to the point. 0.81. What is the ratio of the Gross enrolment ratio (%) in Tertiary schools in 2000 to that in 2003?
Your answer should be compact. 0.94. What is the ratio of the Gross enrolment ratio (%) of Pre-primary schools in 2000 to that in 2004?
Make the answer very short. 0.6. What is the ratio of the Gross enrolment ratio (%) in Primary schools in 2000 to that in 2004?
Keep it short and to the point. 0.74. What is the ratio of the Gross enrolment ratio (%) of Secondary schools in 2000 to that in 2004?
Provide a short and direct response. 0.74. What is the ratio of the Gross enrolment ratio (%) in Tertiary schools in 2000 to that in 2004?
Offer a very short reply. 0.88. What is the ratio of the Gross enrolment ratio (%) in Pre-primary schools in 2000 to that in 2005?
Give a very brief answer. 0.45. What is the ratio of the Gross enrolment ratio (%) of Primary schools in 2000 to that in 2005?
Your answer should be very brief. 0.74. What is the ratio of the Gross enrolment ratio (%) of Secondary schools in 2000 to that in 2005?
Your answer should be compact. 0.7. What is the ratio of the Gross enrolment ratio (%) of Tertiary schools in 2000 to that in 2005?
Offer a very short reply. 0.78. What is the ratio of the Gross enrolment ratio (%) of Pre-primary schools in 2000 to that in 2006?
Provide a succinct answer. 0.45. What is the ratio of the Gross enrolment ratio (%) of Primary schools in 2000 to that in 2006?
Offer a very short reply. 0.72. What is the ratio of the Gross enrolment ratio (%) in Secondary schools in 2000 to that in 2006?
Provide a short and direct response. 0.63. What is the ratio of the Gross enrolment ratio (%) in Tertiary schools in 2000 to that in 2006?
Offer a very short reply. 0.82. What is the ratio of the Gross enrolment ratio (%) of Pre-primary schools in 2001 to that in 2002?
Provide a short and direct response. 0.92. What is the ratio of the Gross enrolment ratio (%) of Primary schools in 2001 to that in 2002?
Your response must be concise. 0.9. What is the ratio of the Gross enrolment ratio (%) of Secondary schools in 2001 to that in 2002?
Keep it short and to the point. 0.91. What is the ratio of the Gross enrolment ratio (%) in Tertiary schools in 2001 to that in 2002?
Provide a short and direct response. 1.06. What is the ratio of the Gross enrolment ratio (%) in Pre-primary schools in 2001 to that in 2003?
Ensure brevity in your answer.  0.92. What is the ratio of the Gross enrolment ratio (%) in Primary schools in 2001 to that in 2003?
Ensure brevity in your answer.  0.81. What is the ratio of the Gross enrolment ratio (%) of Secondary schools in 2001 to that in 2003?
Make the answer very short. 0.87. What is the ratio of the Gross enrolment ratio (%) in Tertiary schools in 2001 to that in 2003?
Your answer should be very brief. 0.94. What is the ratio of the Gross enrolment ratio (%) of Pre-primary schools in 2001 to that in 2004?
Offer a terse response. 0.87. What is the ratio of the Gross enrolment ratio (%) in Primary schools in 2001 to that in 2004?
Keep it short and to the point. 0.8. What is the ratio of the Gross enrolment ratio (%) of Secondary schools in 2001 to that in 2004?
Keep it short and to the point. 0.79. What is the ratio of the Gross enrolment ratio (%) in Tertiary schools in 2001 to that in 2004?
Ensure brevity in your answer.  0.88. What is the ratio of the Gross enrolment ratio (%) in Pre-primary schools in 2001 to that in 2005?
Offer a terse response. 0.65. What is the ratio of the Gross enrolment ratio (%) of Primary schools in 2001 to that in 2005?
Provide a short and direct response. 0.79. What is the ratio of the Gross enrolment ratio (%) in Secondary schools in 2001 to that in 2005?
Keep it short and to the point. 0.75. What is the ratio of the Gross enrolment ratio (%) of Tertiary schools in 2001 to that in 2005?
Your answer should be compact. 0.78. What is the ratio of the Gross enrolment ratio (%) in Pre-primary schools in 2001 to that in 2006?
Your answer should be compact. 0.66. What is the ratio of the Gross enrolment ratio (%) of Primary schools in 2001 to that in 2006?
Offer a terse response. 0.78. What is the ratio of the Gross enrolment ratio (%) of Secondary schools in 2001 to that in 2006?
Make the answer very short. 0.67. What is the ratio of the Gross enrolment ratio (%) in Tertiary schools in 2001 to that in 2006?
Your answer should be compact. 0.82. What is the ratio of the Gross enrolment ratio (%) in Primary schools in 2002 to that in 2003?
Offer a terse response. 0.9. What is the ratio of the Gross enrolment ratio (%) in Secondary schools in 2002 to that in 2003?
Ensure brevity in your answer.  0.95. What is the ratio of the Gross enrolment ratio (%) in Tertiary schools in 2002 to that in 2003?
Your answer should be very brief. 0.89. What is the ratio of the Gross enrolment ratio (%) of Pre-primary schools in 2002 to that in 2004?
Give a very brief answer. 0.95. What is the ratio of the Gross enrolment ratio (%) in Primary schools in 2002 to that in 2004?
Make the answer very short. 0.88. What is the ratio of the Gross enrolment ratio (%) of Secondary schools in 2002 to that in 2004?
Your answer should be compact. 0.87. What is the ratio of the Gross enrolment ratio (%) in Tertiary schools in 2002 to that in 2004?
Provide a succinct answer. 0.83. What is the ratio of the Gross enrolment ratio (%) of Pre-primary schools in 2002 to that in 2005?
Your response must be concise. 0.71. What is the ratio of the Gross enrolment ratio (%) of Primary schools in 2002 to that in 2005?
Your response must be concise. 0.88. What is the ratio of the Gross enrolment ratio (%) of Secondary schools in 2002 to that in 2005?
Offer a very short reply. 0.82. What is the ratio of the Gross enrolment ratio (%) in Tertiary schools in 2002 to that in 2005?
Offer a terse response. 0.74. What is the ratio of the Gross enrolment ratio (%) of Pre-primary schools in 2002 to that in 2006?
Provide a succinct answer. 0.72. What is the ratio of the Gross enrolment ratio (%) in Primary schools in 2002 to that in 2006?
Provide a short and direct response. 0.87. What is the ratio of the Gross enrolment ratio (%) in Secondary schools in 2002 to that in 2006?
Keep it short and to the point. 0.74. What is the ratio of the Gross enrolment ratio (%) in Tertiary schools in 2002 to that in 2006?
Your answer should be very brief. 0.77. What is the ratio of the Gross enrolment ratio (%) in Pre-primary schools in 2003 to that in 2004?
Your answer should be compact. 0.94. What is the ratio of the Gross enrolment ratio (%) in Primary schools in 2003 to that in 2004?
Make the answer very short. 0.99. What is the ratio of the Gross enrolment ratio (%) of Secondary schools in 2003 to that in 2004?
Offer a very short reply. 0.91. What is the ratio of the Gross enrolment ratio (%) of Tertiary schools in 2003 to that in 2004?
Offer a very short reply. 0.93. What is the ratio of the Gross enrolment ratio (%) of Pre-primary schools in 2003 to that in 2005?
Your answer should be compact. 0.7. What is the ratio of the Gross enrolment ratio (%) of Primary schools in 2003 to that in 2005?
Ensure brevity in your answer.  0.99. What is the ratio of the Gross enrolment ratio (%) of Secondary schools in 2003 to that in 2005?
Keep it short and to the point. 0.86. What is the ratio of the Gross enrolment ratio (%) in Tertiary schools in 2003 to that in 2005?
Provide a succinct answer. 0.83. What is the ratio of the Gross enrolment ratio (%) in Pre-primary schools in 2003 to that in 2006?
Ensure brevity in your answer.  0.71. What is the ratio of the Gross enrolment ratio (%) in Primary schools in 2003 to that in 2006?
Offer a very short reply. 0.97. What is the ratio of the Gross enrolment ratio (%) in Secondary schools in 2003 to that in 2006?
Your answer should be very brief. 0.77. What is the ratio of the Gross enrolment ratio (%) of Tertiary schools in 2003 to that in 2006?
Offer a very short reply. 0.87. What is the ratio of the Gross enrolment ratio (%) in Pre-primary schools in 2004 to that in 2005?
Provide a short and direct response. 0.75. What is the ratio of the Gross enrolment ratio (%) of Primary schools in 2004 to that in 2005?
Keep it short and to the point. 1. What is the ratio of the Gross enrolment ratio (%) in Secondary schools in 2004 to that in 2005?
Offer a terse response. 0.94. What is the ratio of the Gross enrolment ratio (%) of Tertiary schools in 2004 to that in 2005?
Provide a succinct answer. 0.89. What is the ratio of the Gross enrolment ratio (%) of Pre-primary schools in 2004 to that in 2006?
Your answer should be compact. 0.76. What is the ratio of the Gross enrolment ratio (%) of Primary schools in 2004 to that in 2006?
Provide a short and direct response. 0.98. What is the ratio of the Gross enrolment ratio (%) of Secondary schools in 2004 to that in 2006?
Give a very brief answer. 0.85. What is the ratio of the Gross enrolment ratio (%) of Tertiary schools in 2004 to that in 2006?
Give a very brief answer. 0.93. What is the ratio of the Gross enrolment ratio (%) in Pre-primary schools in 2005 to that in 2006?
Offer a very short reply. 1.01. What is the ratio of the Gross enrolment ratio (%) in Primary schools in 2005 to that in 2006?
Provide a short and direct response. 0.98. What is the ratio of the Gross enrolment ratio (%) of Secondary schools in 2005 to that in 2006?
Provide a succinct answer. 0.9. What is the ratio of the Gross enrolment ratio (%) of Tertiary schools in 2005 to that in 2006?
Your response must be concise. 1.04. What is the difference between the highest and the second highest Gross enrolment ratio (%) in Pre-primary schools?
Provide a short and direct response. 0.02. What is the difference between the highest and the second highest Gross enrolment ratio (%) of Primary schools?
Offer a terse response. 1.34. What is the difference between the highest and the second highest Gross enrolment ratio (%) in Secondary schools?
Provide a short and direct response. 0.6. What is the difference between the highest and the second highest Gross enrolment ratio (%) in Tertiary schools?
Make the answer very short. 0.04. What is the difference between the highest and the lowest Gross enrolment ratio (%) in Pre-primary schools?
Provide a short and direct response. 0.96. What is the difference between the highest and the lowest Gross enrolment ratio (%) in Primary schools?
Keep it short and to the point. 19.02. What is the difference between the highest and the lowest Gross enrolment ratio (%) in Secondary schools?
Your answer should be compact. 2.17. What is the difference between the highest and the lowest Gross enrolment ratio (%) in Tertiary schools?
Your answer should be compact. 0.25. 